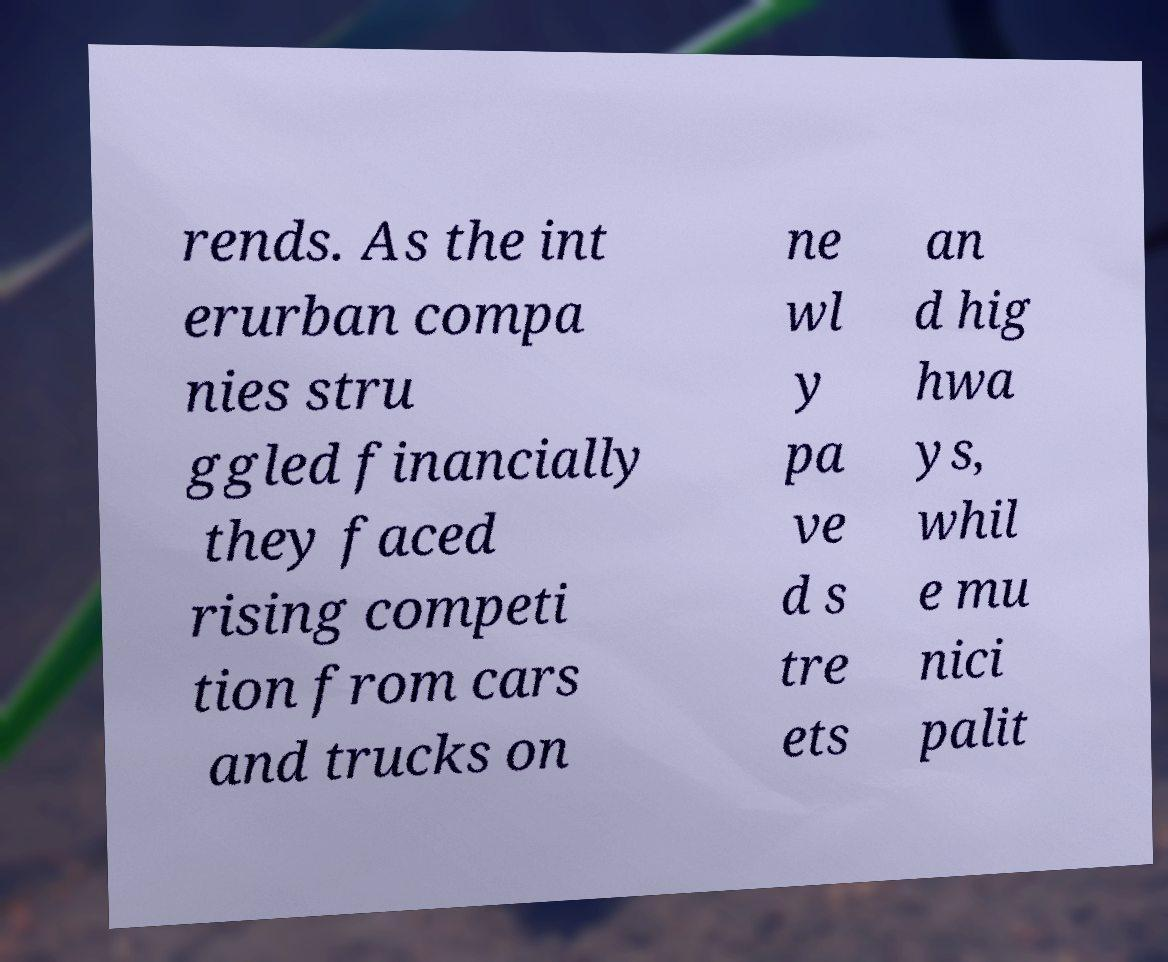I need the written content from this picture converted into text. Can you do that? rends. As the int erurban compa nies stru ggled financially they faced rising competi tion from cars and trucks on ne wl y pa ve d s tre ets an d hig hwa ys, whil e mu nici palit 